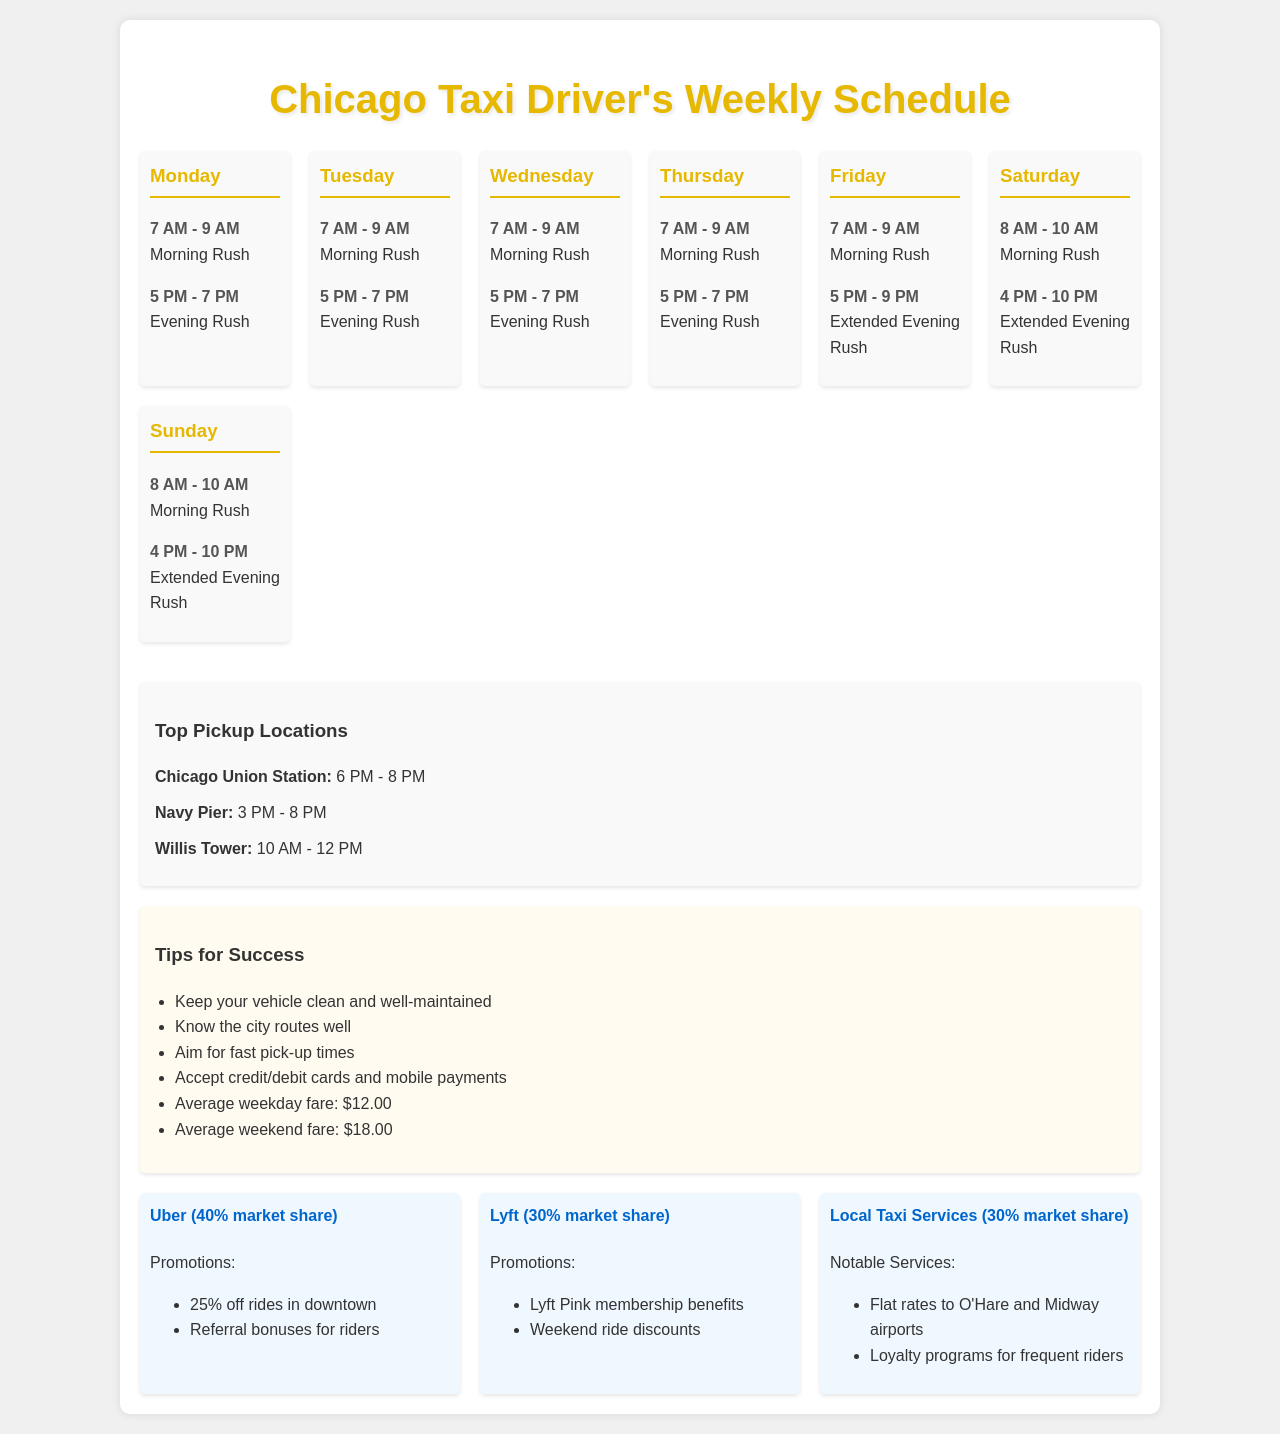What are the morning rush hours on Monday? The morning rush hours on Monday are from 7 AM to 9 AM.
Answer: 7 AM - 9 AM Which location is a top pickup spot from 6 PM to 8 PM? The location that is a top pickup spot during that time is Chicago Union Station.
Answer: Chicago Union Station What percentage of the market does Uber hold? Uber holds a market share of 40%.
Answer: 40% What is the average weekday fare mentioned in the document? The average weekday fare is stated to be $12.00.
Answer: $12.00 What notable service do local taxi services offer? Local taxi services offer flat rates to O'Hare and Midway airports.
Answer: Flat rates to O'Hare and Midway airports On which day is the evening rush extended until 9 PM? The evening rush is extended until 9 PM on Friday.
Answer: Friday What type of promotions does Lyft offer? Lyft offers membership benefits related to Lyft Pink.
Answer: Lyft Pink membership benefits What time does the Saturday morning rush begin? The Saturday morning rush begins at 8 AM.
Answer: 8 AM What is the average weekend fare? The average weekend fare is stated to be $18.00.
Answer: $18.00 